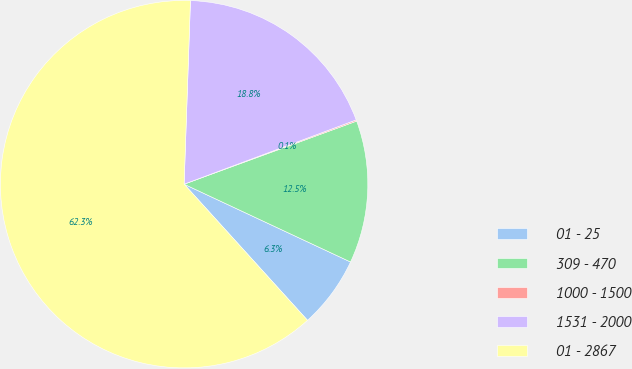Convert chart to OTSL. <chart><loc_0><loc_0><loc_500><loc_500><pie_chart><fcel>01 - 25<fcel>309 - 470<fcel>1000 - 1500<fcel>1531 - 2000<fcel>01 - 2867<nl><fcel>6.32%<fcel>12.54%<fcel>0.11%<fcel>18.76%<fcel>62.27%<nl></chart> 